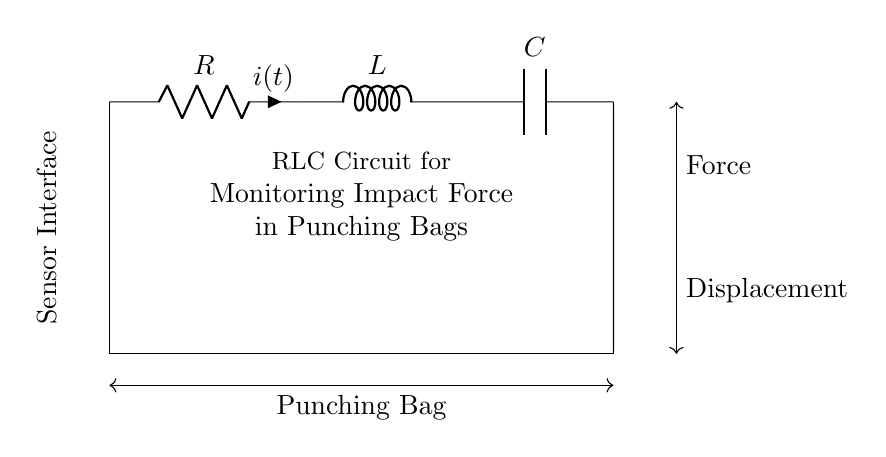What components are in the circuit? The circuit contains a resistor, an inductor, and a capacitor, which are labeled as R, L, and C, respectively.
Answer: Resistor, Inductor, Capacitor What does the 'i' represent in this circuit? The 'i' is labeled beside the resistor and represents the current flowing through the resistor at time 't'.
Answer: Current What is the purpose of this RLC circuit? The circuit diagram indicates that it is for monitoring impact force in punching bags, as stated in the text within the circuit.
Answer: Monitoring impact force What is the connection type between components? The circuit components are connected in series, which can be inferred from the continuous path from the resistor to the inductor to the capacitor.
Answer: Series How does this circuit respond to changes in force? The combination of resistor, inductor, and capacitor will have a dynamic response to force changes, affecting the behavior of current and voltage over time.
Answer: Dynamic response What does the 'Sensor Interface' represent? The 'Sensor Interface' noted in the diagram suggests that this is where the circuit connects to the sensor measuring the impact force on the punching bag.
Answer: Sensor Interface What type of circuit is this? This circuit is an RLC circuit, which is characterized by the presence of a resistor, inductor, and capacitor in combination.
Answer: RLC circuit 